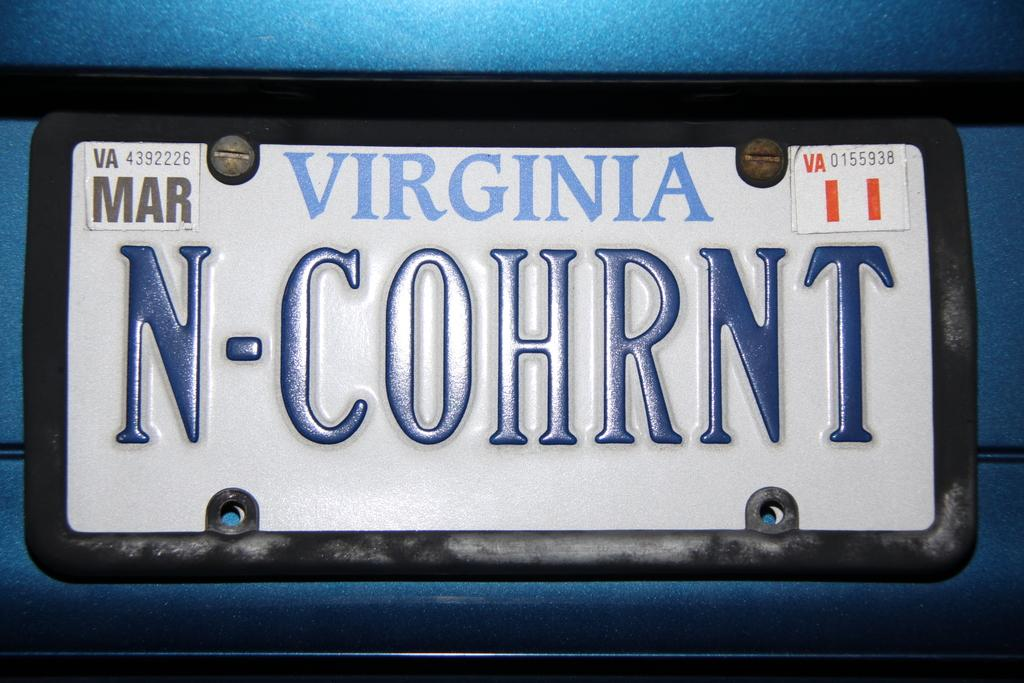What can be seen in the image related to a vehicle? There is a vehicle registration plate in the image. What is present on the vehicle registration plate? Text is written on the vehicle registration plate. What type of rice is being cooked in the image? There is no rice present in the image; it only features a vehicle registration plate with text on it. 